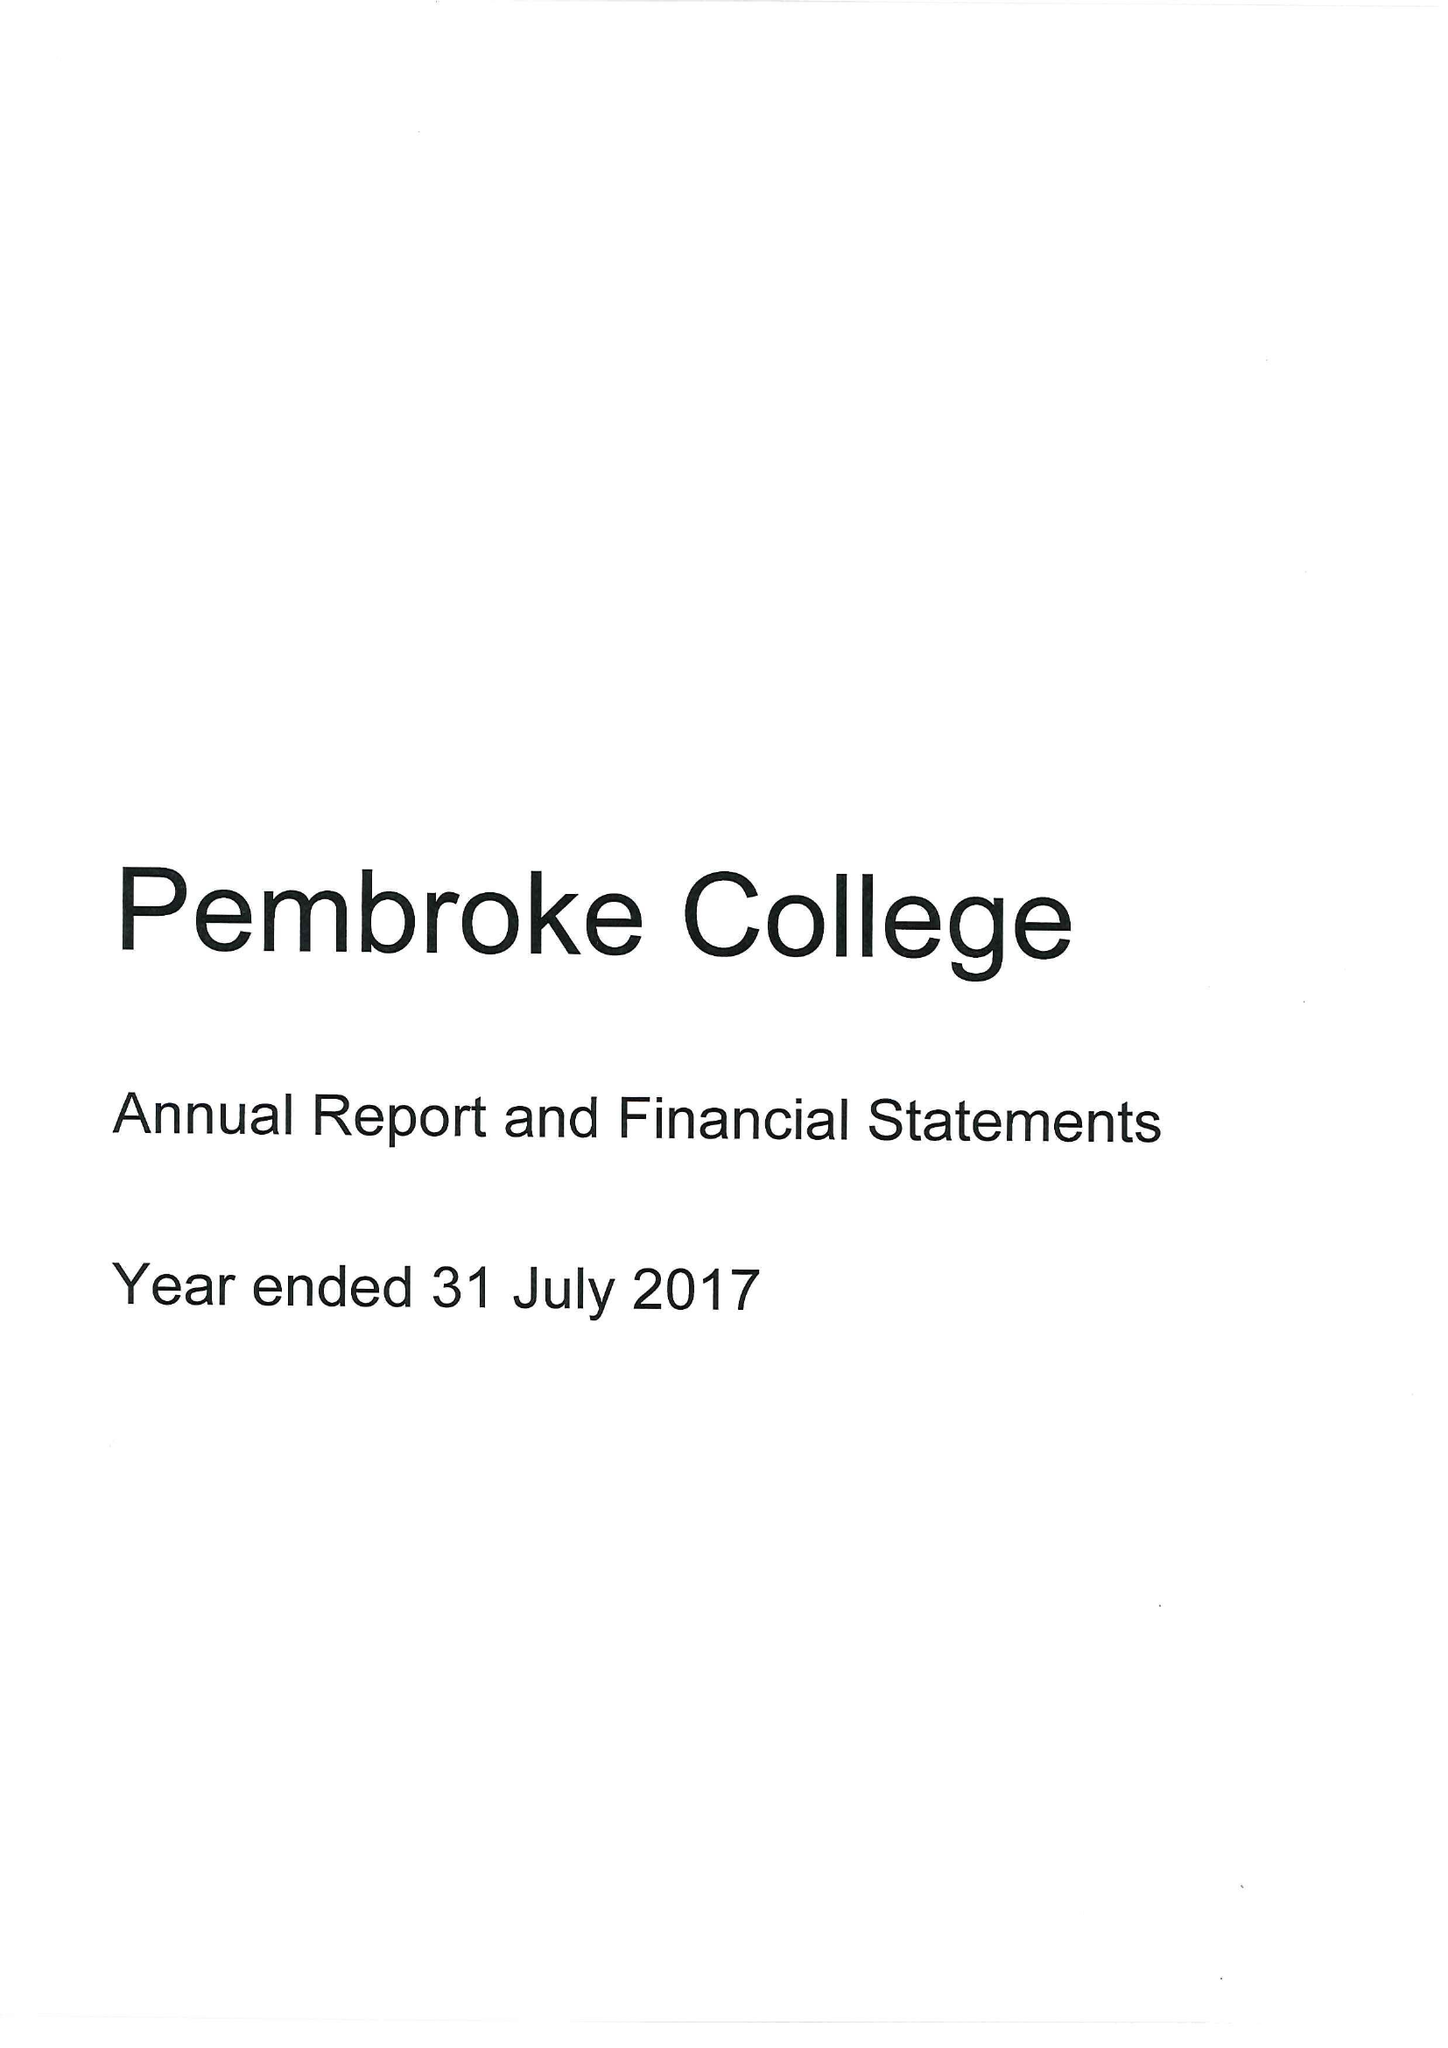What is the value for the charity_name?
Answer the question using a single word or phrase. Master Fellows and Scholars Of Pembroke College 